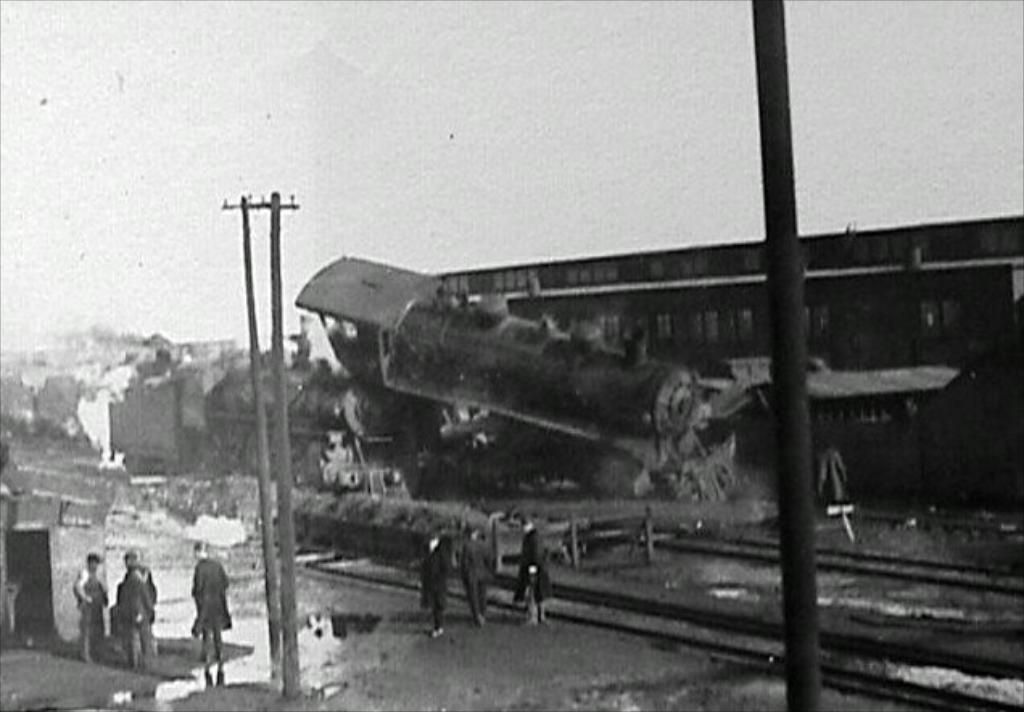What is the main subject of the picture? The main subject of the picture is a collapsed train. Are there any people present in the image? Yes, there are people standing beside the collapsed train. What can be seen in the background of the picture? There is a building in the background of the picture. How many bikes are parked near the collapsed train in the image? There are no bikes present in the image; it features a collapsed train and people standing beside it. 